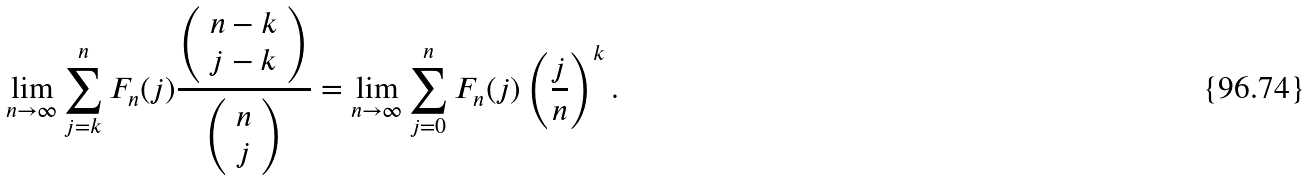<formula> <loc_0><loc_0><loc_500><loc_500>\lim _ { n \rightarrow \infty } \sum _ { j = k } ^ { n } F _ { n } ( j ) \frac { \left ( \begin{array} { c } n - k \\ j - k \\ \end{array} \right ) } { \left ( \begin{array} { c } n \\ j \\ \end{array} \right ) } = \lim _ { n \rightarrow \infty } \sum _ { j = 0 } ^ { n } F _ { n } ( j ) \left ( \frac { j } { n } \right ) ^ { k } .</formula> 